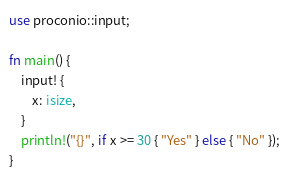<code> <loc_0><loc_0><loc_500><loc_500><_Rust_>use proconio::input;

fn main() {
    input! {
        x: isize,
    }
    println!("{}", if x >= 30 { "Yes" } else { "No" });
}
</code> 